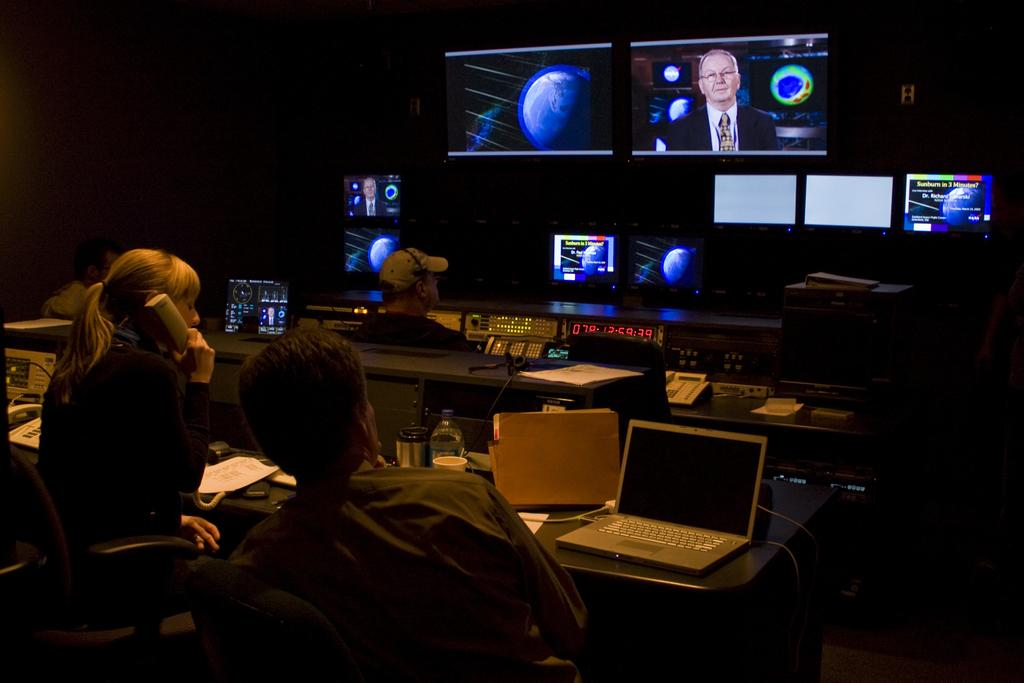<image>
Summarize the visual content of the image. Red ticker numbers that say 078125939 in front of two screens in a dark room. 